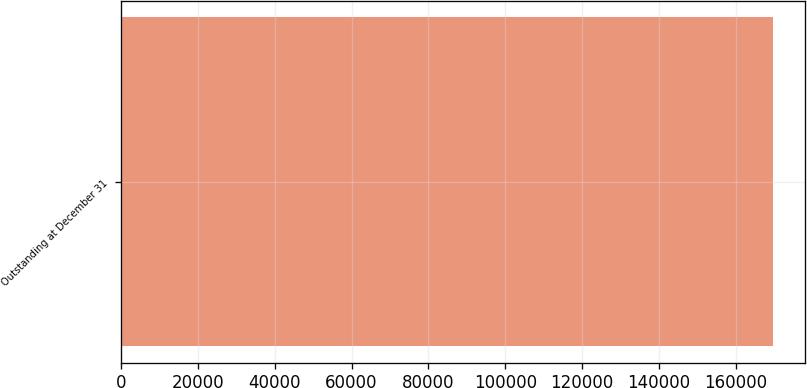<chart> <loc_0><loc_0><loc_500><loc_500><bar_chart><fcel>Outstanding at December 31<nl><fcel>169587<nl></chart> 